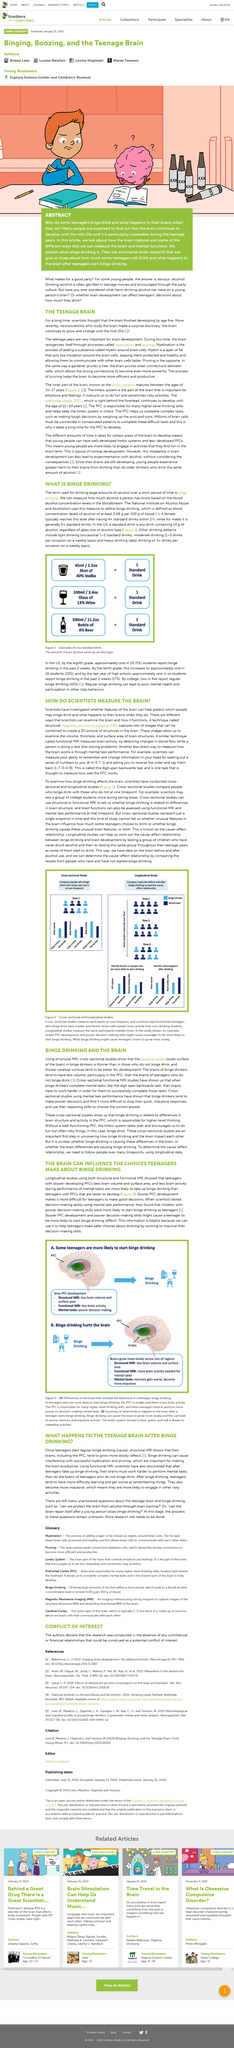Give some essential details in this illustration. Binge drinking is the term used for consuming large amounts of alcohol over a short period of time. According to the article, the first number in the series of numbers read out to the participant in the digit span backwards task is 8. The title of the article poses the question of how scientists measure the brain. Binge drinking has a negative impact on the mental abilities of teenagers, causing them to perform worse on memory tasks and exhibit increased impulsivity. Heavy drinking is defined as daily drinking or having three or more drinks on a single occasion during a weekly period. 